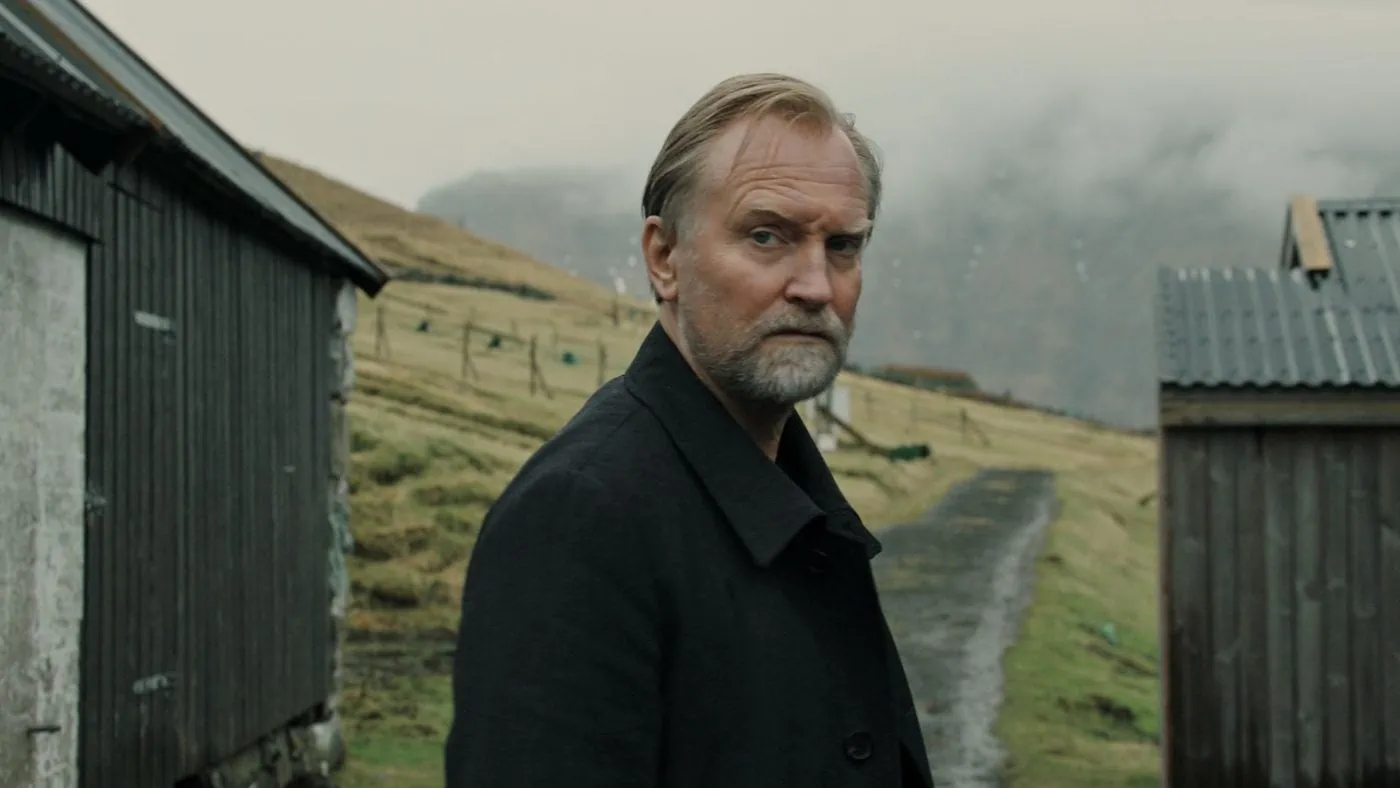What are the key elements in this picture? In this image, a man is captured in a moment of quiet contemplation, dressed in a dark coat that contrasts sharply with the grassy hill behind him. His facial expression is serious as he looks off to the side, suggesting deep thought or introspection. The setting is rustic with a wooden shed and a fence in the background, adding to the overall serene and somewhat somber atmosphere. The sky is overcast, with clouds casting a muted light over the scene, enriching the sense of solemnity and seclusion. 